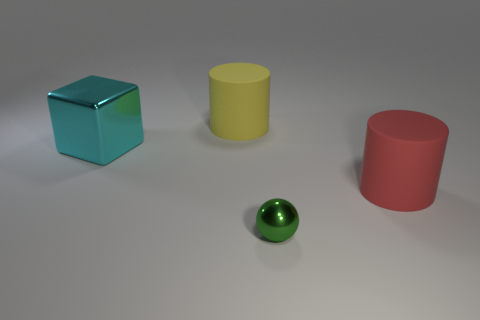There is a big matte object that is in front of the big yellow matte cylinder; is it the same color as the rubber cylinder that is behind the large red object?
Provide a short and direct response. No. Is there a red block that has the same material as the cyan cube?
Offer a terse response. No. How many red things are large rubber objects or large things?
Give a very brief answer. 1. Are there more tiny spheres in front of the red thing than cyan metallic cylinders?
Provide a succinct answer. Yes. Is the green metal thing the same size as the cube?
Offer a very short reply. No. What is the color of the tiny thing that is the same material as the large cube?
Ensure brevity in your answer.  Green. Are there the same number of big cyan objects in front of the red object and cyan things on the left side of the small green shiny thing?
Offer a very short reply. No. What shape is the big matte object that is behind the rubber thing that is in front of the large cyan metallic block?
Offer a very short reply. Cylinder. There is a block that is the same size as the yellow rubber object; what is its color?
Make the answer very short. Cyan. Is the number of big cyan metal things that are in front of the small green metallic thing the same as the number of big red matte objects?
Provide a succinct answer. No. 